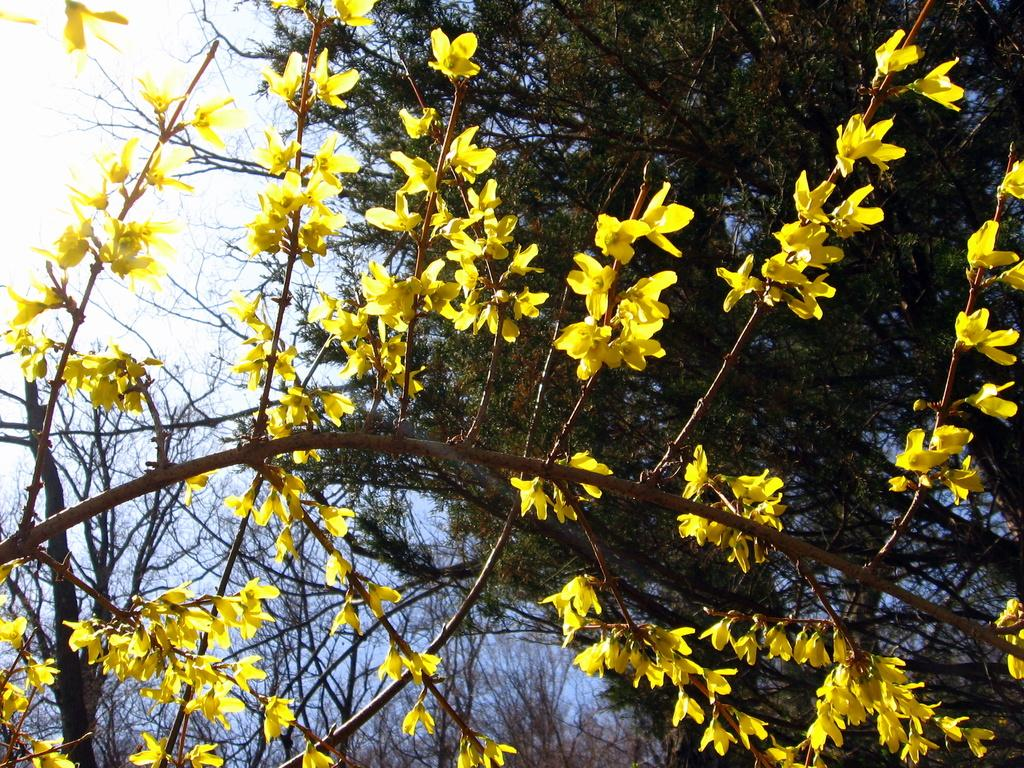What type of vegetation is present in the image? There are many trees in the image. Are there any additional features on the trees? Yes, there are flowers on the trees. What part of the natural environment is visible in the image? The sky is visible in the image. Where is the playground located in the image? There is no playground present in the image; it features trees and flowers. What type of shape is the son making in the image? There is no son present in the image, and therefore no shape can be attributed to him. 